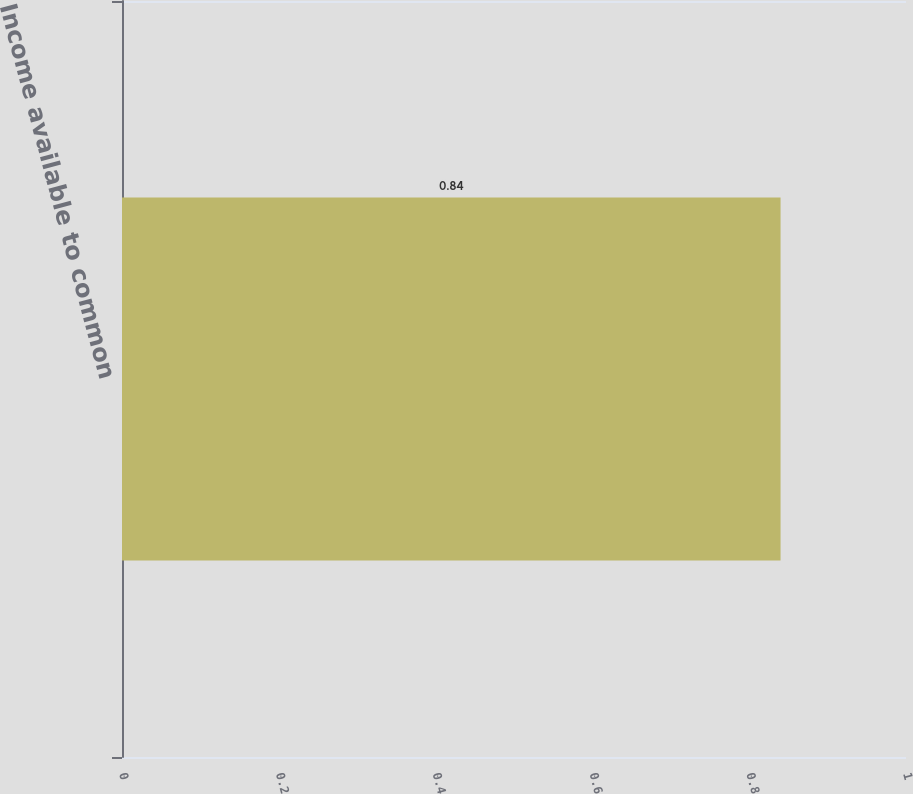<chart> <loc_0><loc_0><loc_500><loc_500><bar_chart><fcel>Income available to common<nl><fcel>0.84<nl></chart> 